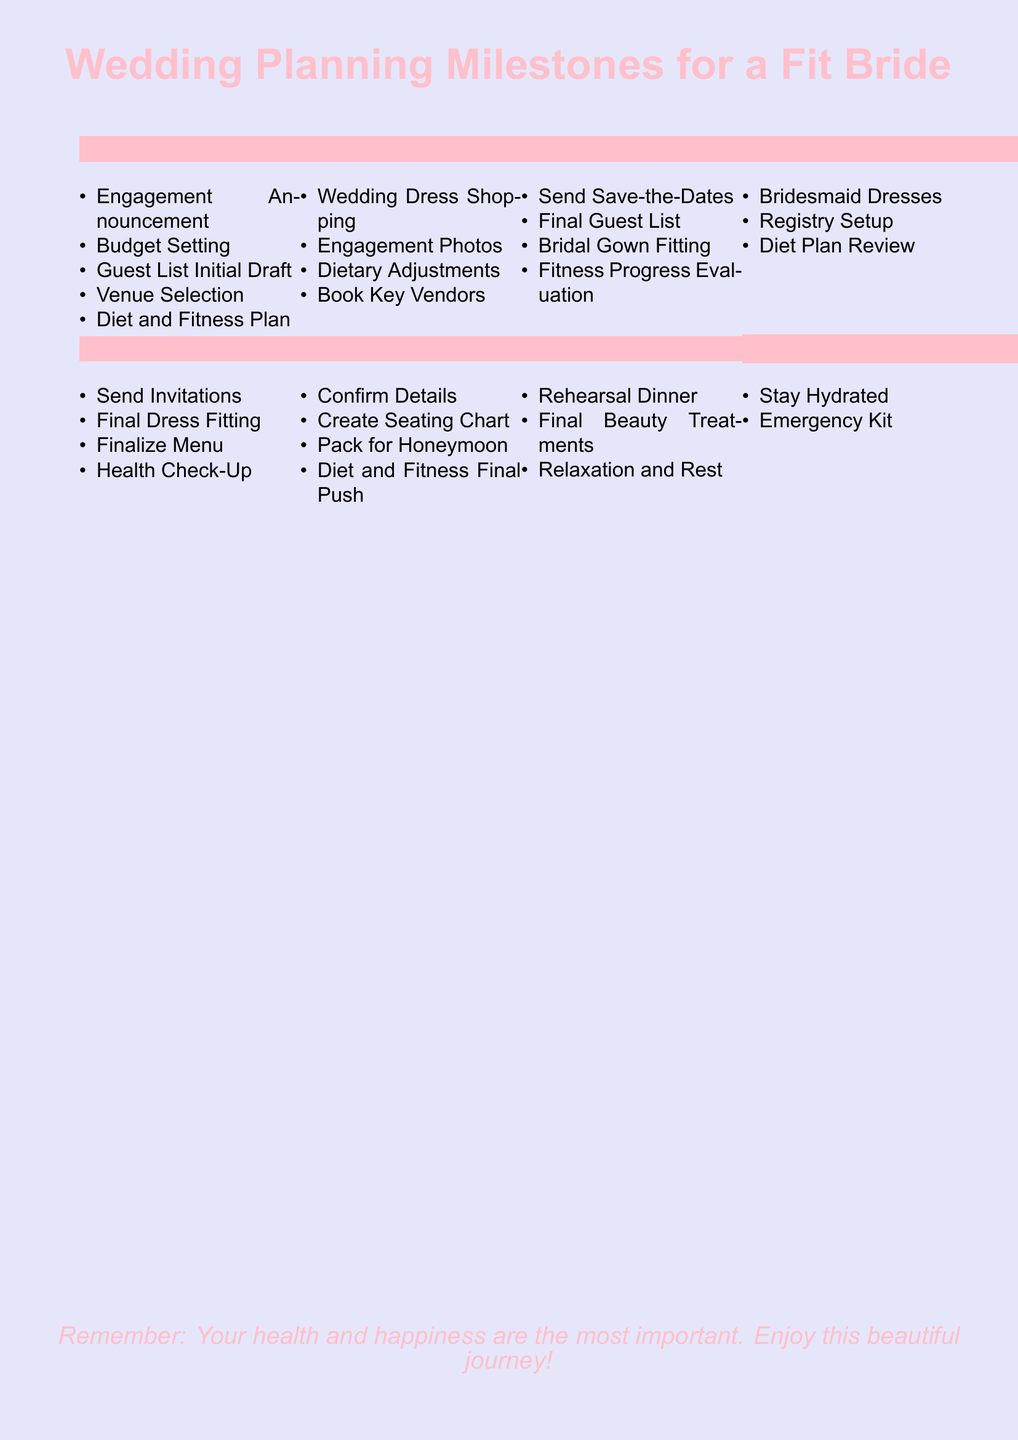What are the initial steps in planning a wedding? The document lists the engagement announcement, budget setting, initial guest list draft, venue selection, and diet and fitness plan as the first steps.
Answer: Engagement Announcement, Budget Setting, Guest List Initial Draft, Venue Selection, Diet and Fitness Plan When should the final guest list be prepared? The final guest list is listed under the section for 6-8 months before the wedding.
Answer: 6-8 Months Before What milestone occurs immediately before the wedding day? The review of the emergency kit is included in the big day section, located at the bottom of the document.
Answer: Emergency Kit How many months before the wedding should dietary adjustments be made? The document specifies that dietary adjustments are made 9-11 months before the wedding.
Answer: 9-11 Months Before What is emphasized as most important in the final note of the document? The document highlights the significance of health and happiness in the final note, stressing personal well-being during the planning process.
Answer: Health and happiness What is the purpose of the "Diet and Fitness Final Push"? This milestone occurs one month before the wedding and signifies the last effort in health and fitness preparations.
Answer: Final effort Which month is dedicated to the bridesmaid dresses? The document states that bridesmaid dresses are addressed 3-5 months before the wedding.
Answer: 3-5 Months Before What is the recommended dietary action 2 months before the wedding? The recommendation includes a diet plan review, listed in the 2 months before section.
Answer: Diet Plan Review 